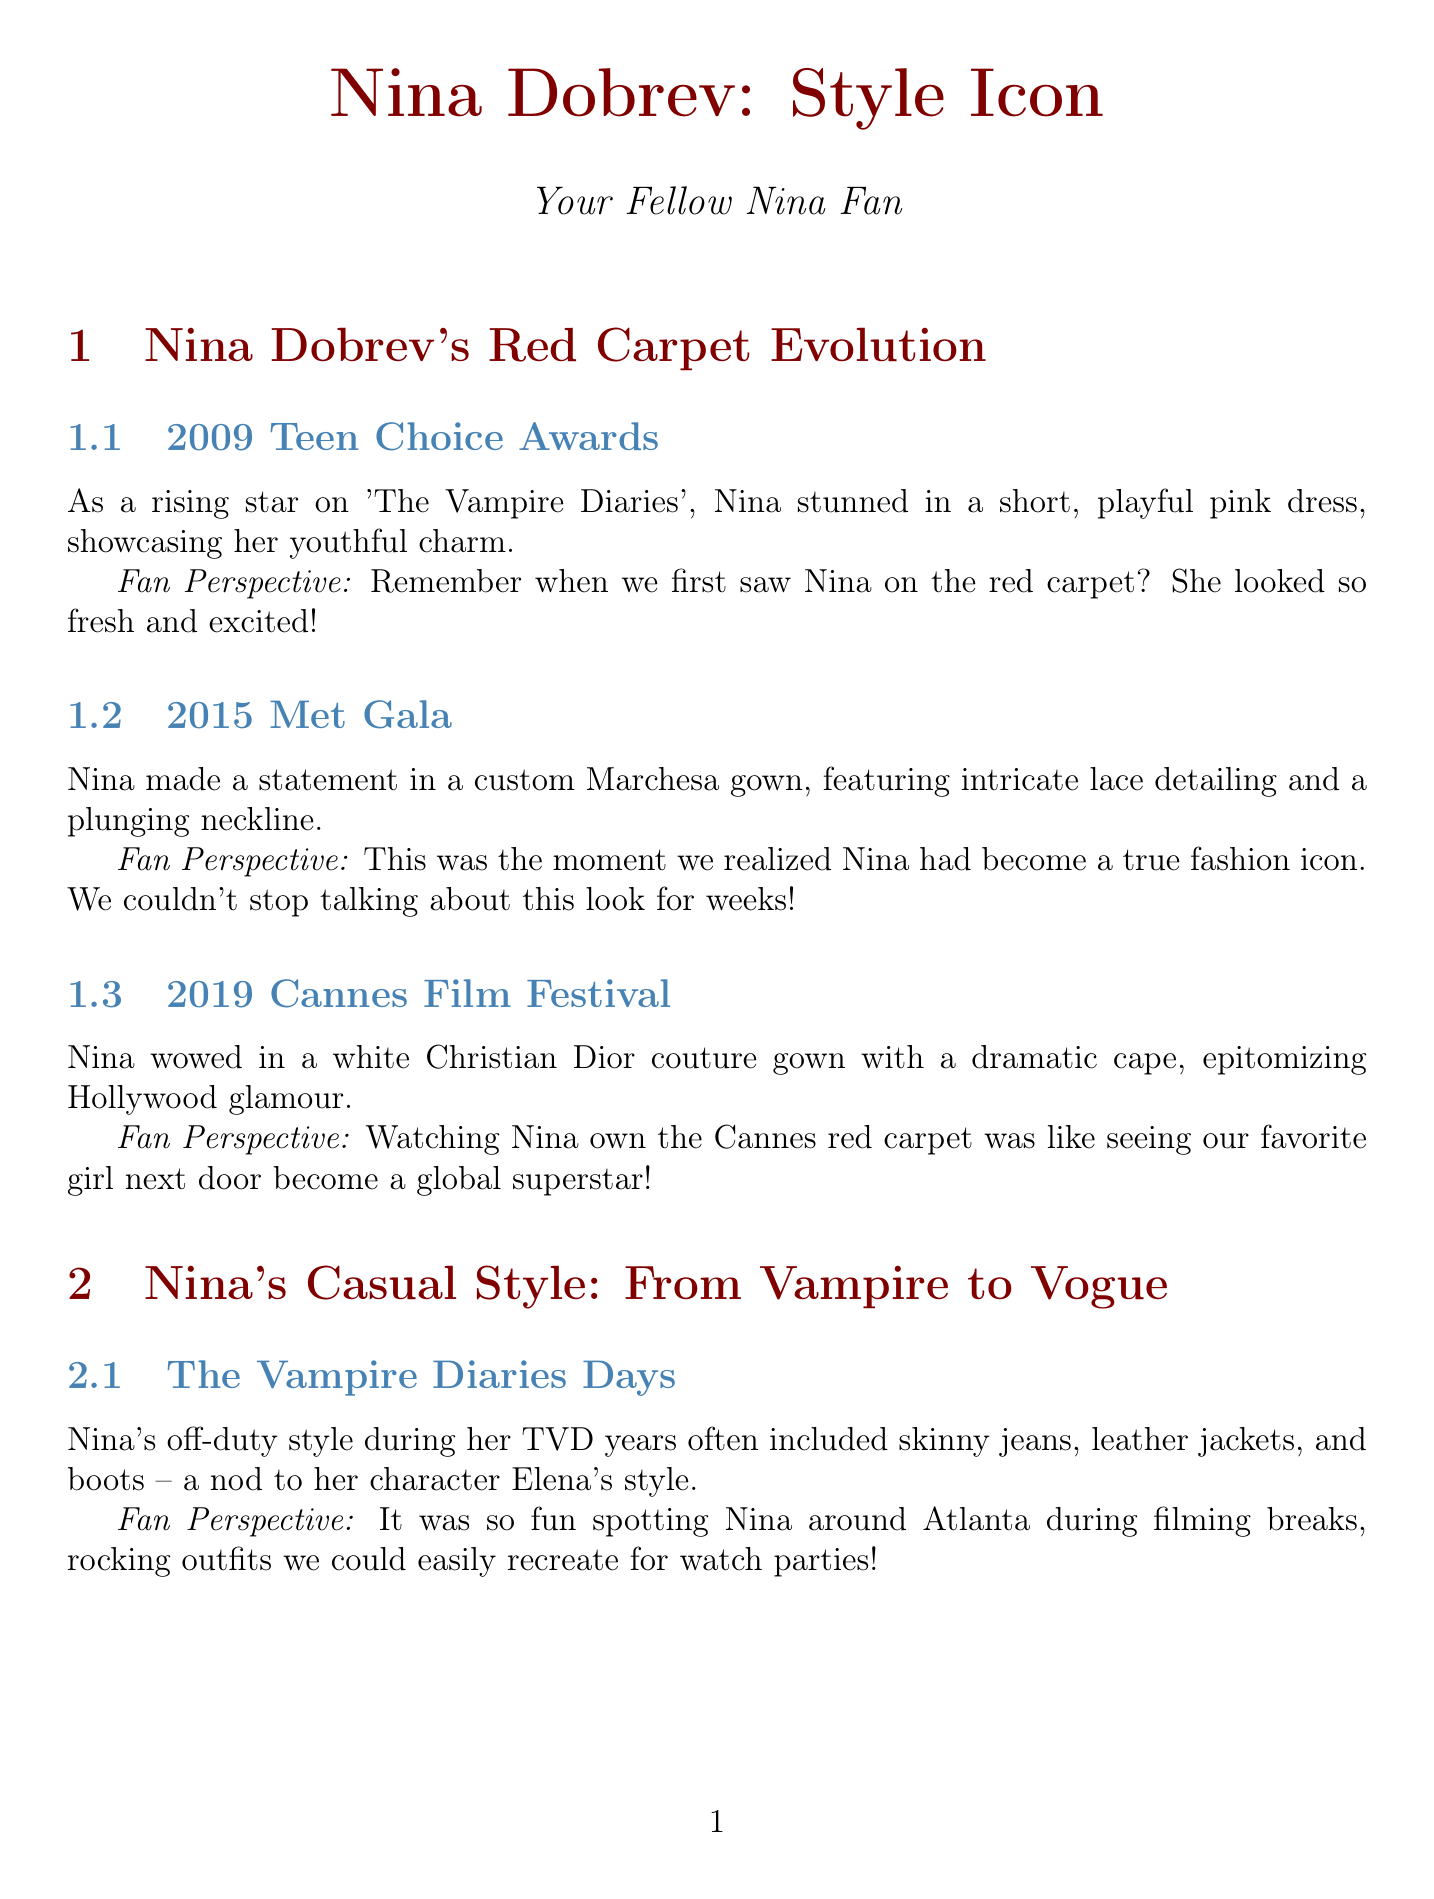What did Nina wear at the 2009 Teen Choice Awards? At the 2009 Teen Choice Awards, Nina wore a short, playful pink dress.
Answer: short, playful pink dress Which fashion item does Nina swear by for comfort and versatility? Nina swears by James Perse t-shirts for their comfort and versatility.
Answer: James Perse t-shirts What year did Nina attend the Met Gala in a custom Marchesa gown? Nina attended the Met Gala in a custom Marchesa gown in 2015.
Answer: 2015 What major style icon has Nina cited as an inspiration? Nina has cited Audrey Hepburn as a major style inspiration.
Answer: Audrey Hepburn How does Nina promote sustainable fashion choices? Nina promotes sustainable fashion choices by incorporating more sustainable and ethical brands on her Instagram.
Answer: eco-friendly brands on her Instagram What type of sunglasses is Nina often spotted wearing? Nina is often spotted in Ray-Ban Wayfarers or cat-eye frames from Celine.
Answer: Ray-Ban Wayfarers or cat-eye frames What was a notable aspect of Nina's style during her "Vampire Diaries" days? Nina's off-duty style during her TVD years included skinny jeans, leather jackets, and boots.
Answer: skinny jeans, leather jackets, and boots How does the newsletter refer to Nina's recent fashion trend? The newsletter refers to Nina's recent fashion trend as "Sustainable and Chic."
Answer: Sustainable and Chic What did Nina wear to the 2019 Cannes Film Festival? Nina wore a white Christian Dior couture gown with a dramatic cape at the 2019 Cannes Film Festival.
Answer: white Christian Dior couture gown with a dramatic cape 